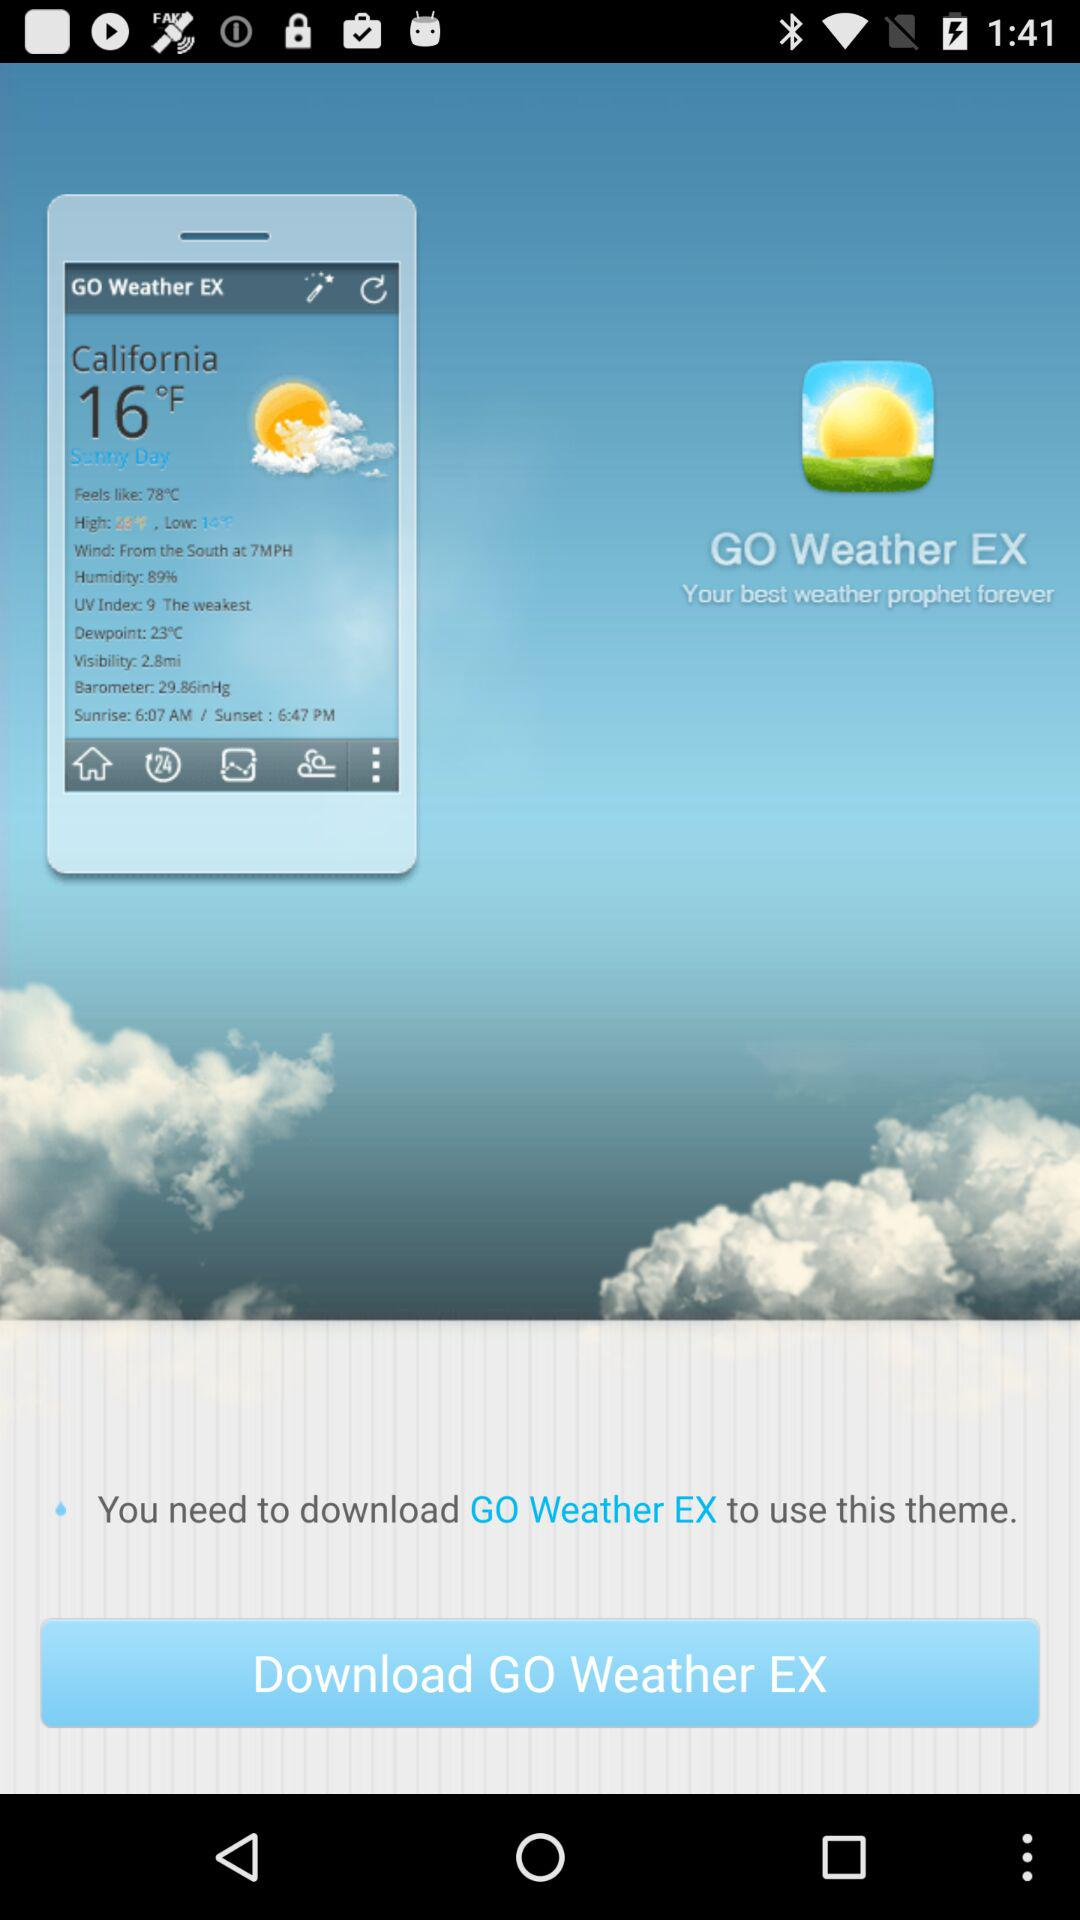What is the name of the application? The name of the application is "GO Weather EX". 